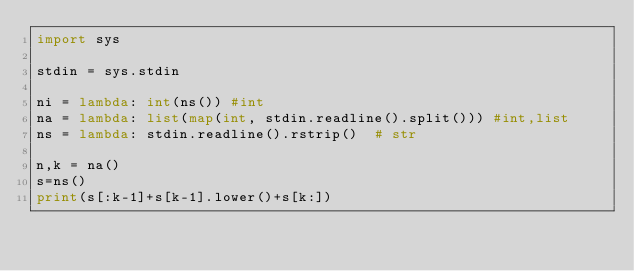Convert code to text. <code><loc_0><loc_0><loc_500><loc_500><_Python_>import sys

stdin = sys.stdin

ni = lambda: int(ns()) #int
na = lambda: list(map(int, stdin.readline().split())) #int,list
ns = lambda: stdin.readline().rstrip()  # str

n,k = na()
s=ns()
print(s[:k-1]+s[k-1].lower()+s[k:])</code> 